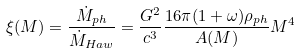<formula> <loc_0><loc_0><loc_500><loc_500>\xi ( M ) = \frac { \dot { M } _ { p h } } { \dot { M } _ { H a w } } = \frac { G ^ { 2 } } { c ^ { 3 } } \frac { 1 6 \pi ( 1 + \omega ) \rho _ { p h } } { A ( M ) } M ^ { 4 }</formula> 